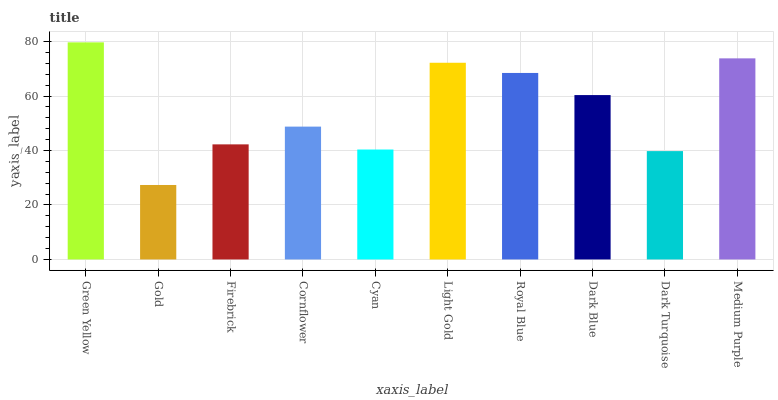Is Gold the minimum?
Answer yes or no. Yes. Is Green Yellow the maximum?
Answer yes or no. Yes. Is Firebrick the minimum?
Answer yes or no. No. Is Firebrick the maximum?
Answer yes or no. No. Is Firebrick greater than Gold?
Answer yes or no. Yes. Is Gold less than Firebrick?
Answer yes or no. Yes. Is Gold greater than Firebrick?
Answer yes or no. No. Is Firebrick less than Gold?
Answer yes or no. No. Is Dark Blue the high median?
Answer yes or no. Yes. Is Cornflower the low median?
Answer yes or no. Yes. Is Cyan the high median?
Answer yes or no. No. Is Green Yellow the low median?
Answer yes or no. No. 